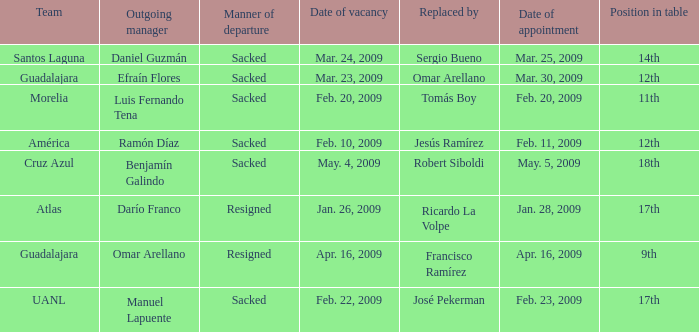What is Position in Table, when Replaced By is "Sergio Bueno"? 14th. 